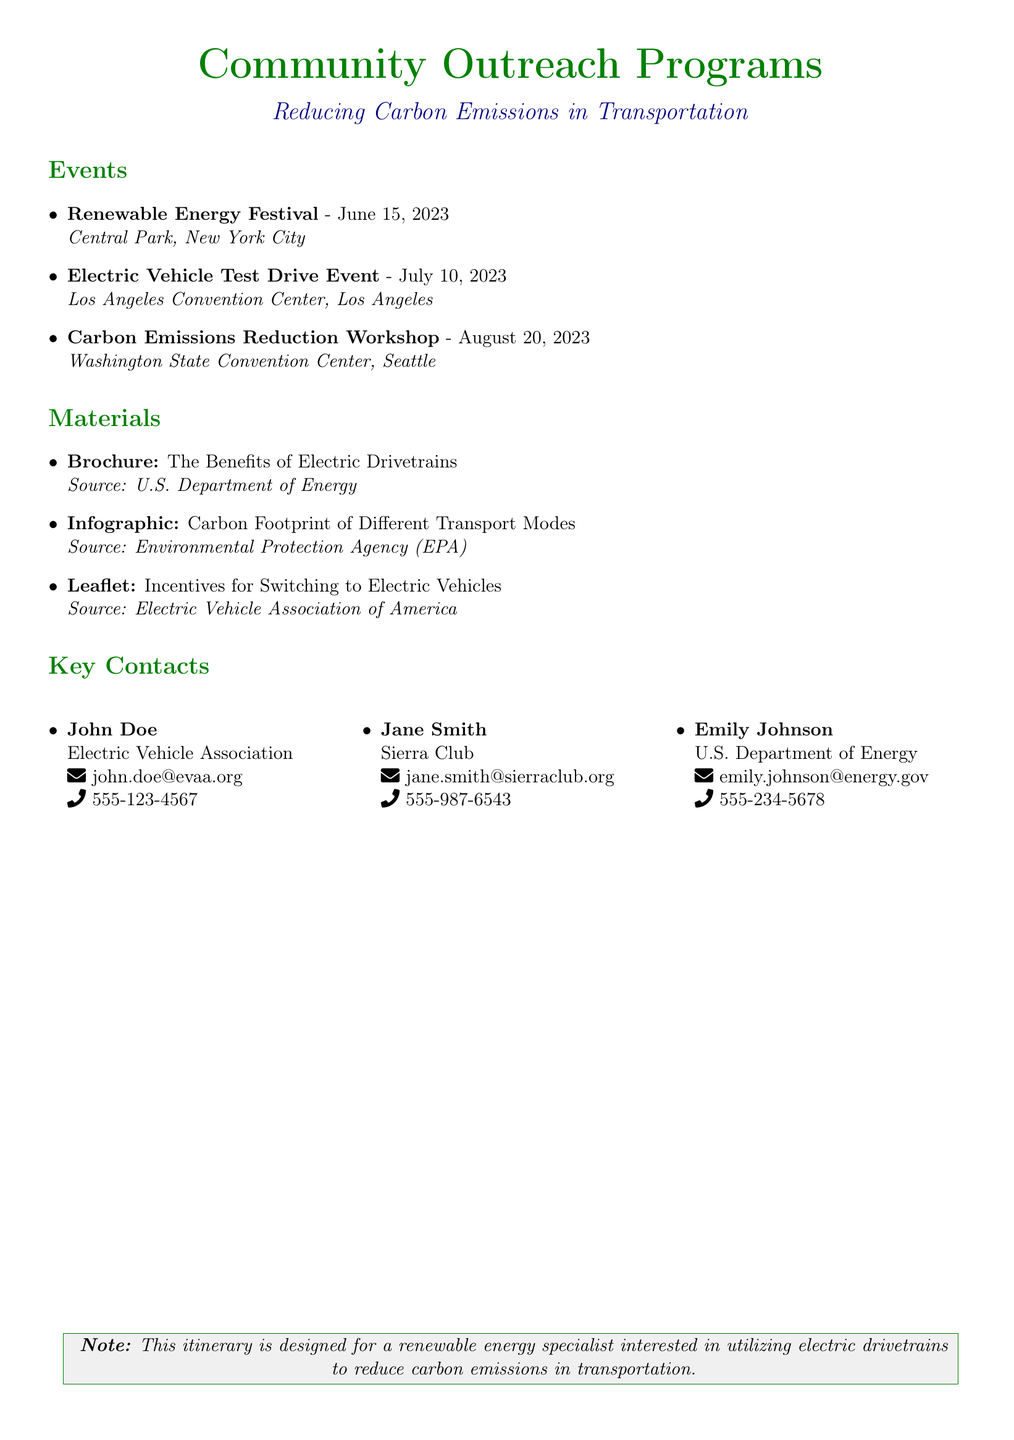What is the date of the Renewable Energy Festival? The date is specified in the events section as June 15, 2023.
Answer: June 15, 2023 Where is the Electric Vehicle Test Drive Event taking place? The location of the event is given as Los Angeles Convention Center, Los Angeles.
Answer: Los Angeles Convention Center, Los Angeles Who is the contact person for the Electric Vehicle Association? The document lists John Doe as the contact person for the Electric Vehicle Association.
Answer: John Doe What material is sourced from the U.S. Department of Energy? The document states that the brochure, "The Benefits of Electric Drivetrains," is from the U.S. Department of Energy.
Answer: The Benefits of Electric Drivetrains How many events are listed in the document? The events section includes three events focused on reducing carbon emissions.
Answer: 3 Which organization is Jane Smith associated with? The document indicates that Jane Smith is associated with the Sierra Club.
Answer: Sierra Club What is the title of the workshop event? The title of the workshop event is provided in the events section as "Carbon Emissions Reduction Workshop."
Answer: Carbon Emissions Reduction Workshop What is the theme of the community outreach programs? The theme is explicitly stated in the title of the document as reducing carbon emissions in transportation.
Answer: Reducing carbon emissions in transportation 